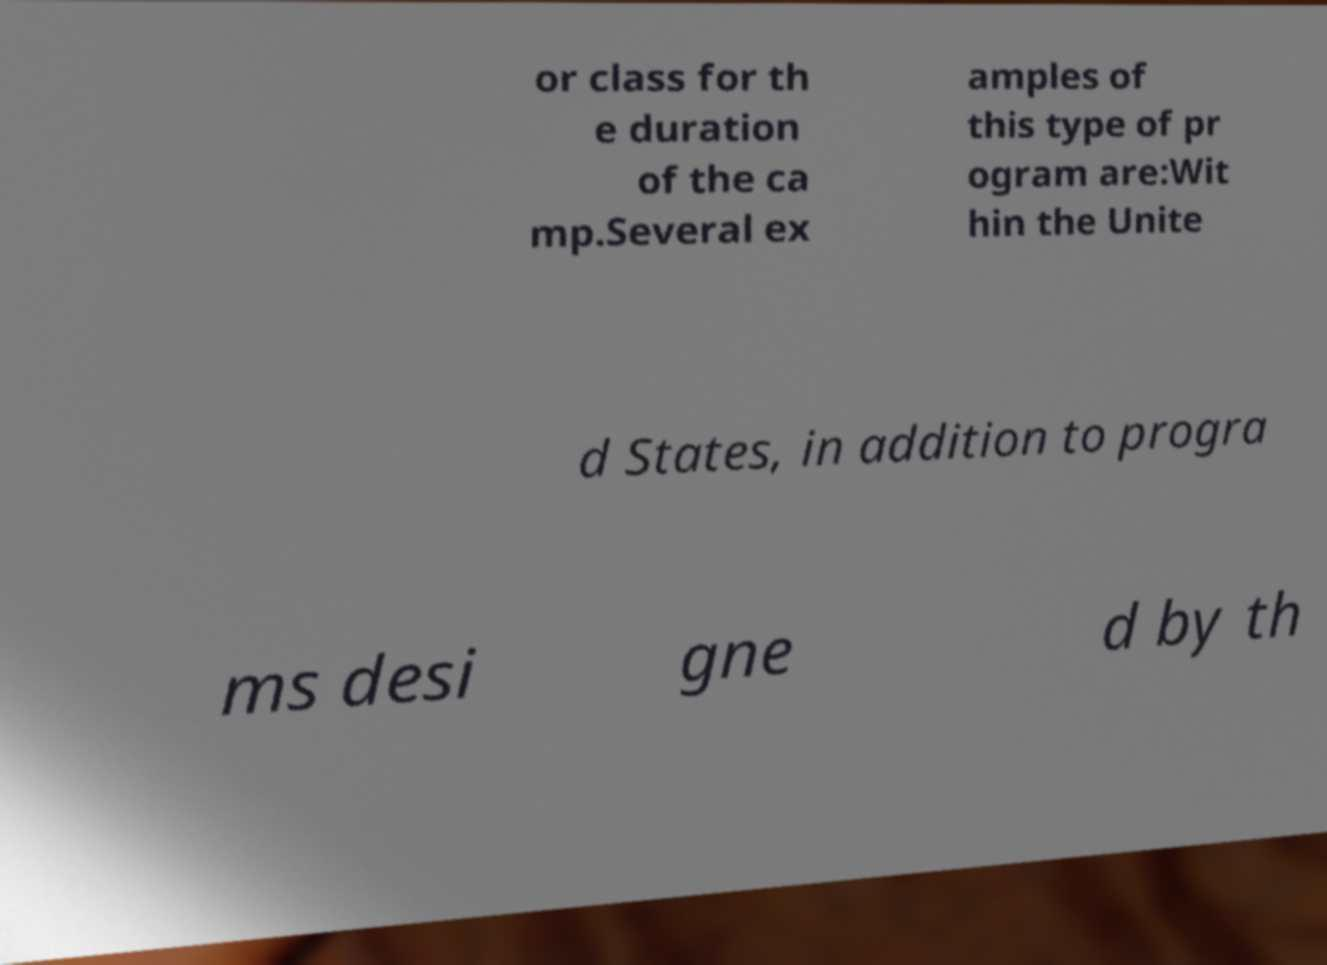Please read and relay the text visible in this image. What does it say? or class for th e duration of the ca mp.Several ex amples of this type of pr ogram are:Wit hin the Unite d States, in addition to progra ms desi gne d by th 